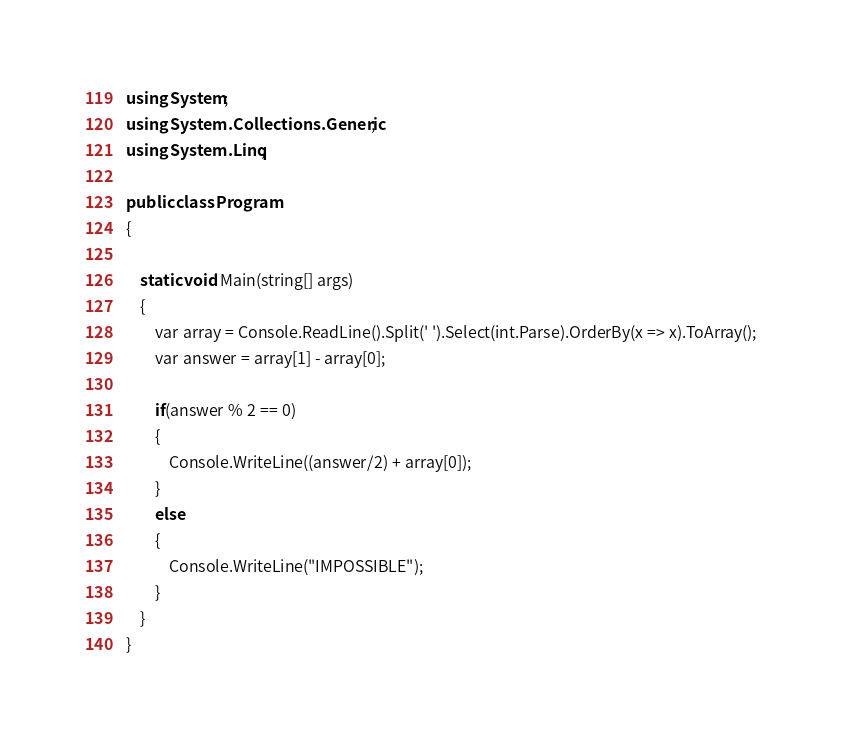Convert code to text. <code><loc_0><loc_0><loc_500><loc_500><_C#_>using System;
using System.Collections.Generic;
using System.Linq;

public class Program
{

	static void Main(string[] args)
	{
		var array = Console.ReadLine().Split(' ').Select(int.Parse).OrderBy(x => x).ToArray();
		var answer = array[1] - array[0];

		if(answer % 2 == 0)
		{
			Console.WriteLine((answer/2) + array[0]);
		}
		else
		{
			Console.WriteLine("IMPOSSIBLE");
		}
	}
}
</code> 